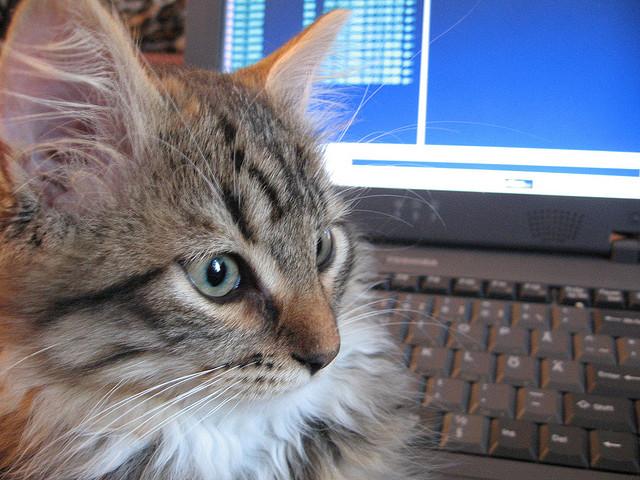Is this cat feral?
Give a very brief answer. No. Is there a computer  here?
Concise answer only. Yes. Does this cat have ear mites?
Write a very short answer. No. 